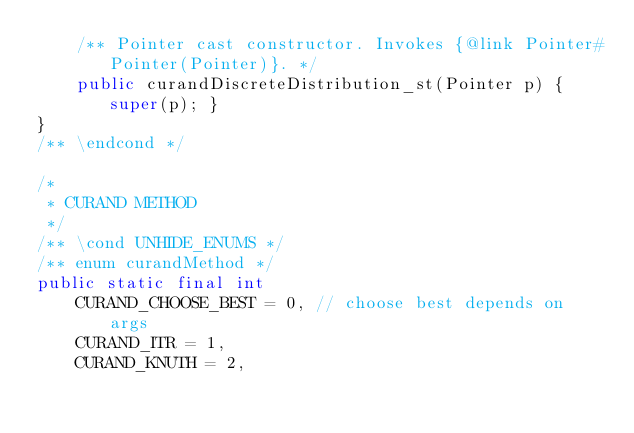Convert code to text. <code><loc_0><loc_0><loc_500><loc_500><_Java_>    /** Pointer cast constructor. Invokes {@link Pointer#Pointer(Pointer)}. */
    public curandDiscreteDistribution_st(Pointer p) { super(p); }
}
/** \endcond */

/*
 * CURAND METHOD
 */
/** \cond UNHIDE_ENUMS */
/** enum curandMethod */
public static final int
    CURAND_CHOOSE_BEST = 0, // choose best depends on args
    CURAND_ITR = 1,
    CURAND_KNUTH = 2,</code> 